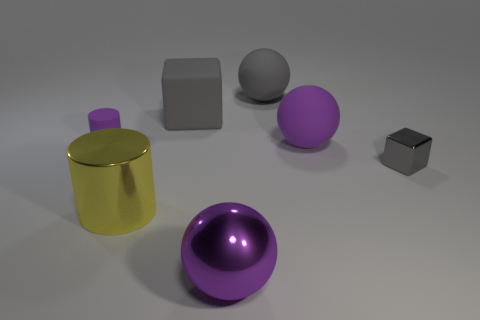Add 1 purple rubber cylinders. How many objects exist? 8 Subtract all balls. How many objects are left? 4 Add 1 tiny gray metal blocks. How many tiny gray metal blocks exist? 2 Subtract 2 gray blocks. How many objects are left? 5 Subtract all tiny shiny blocks. Subtract all tiny blocks. How many objects are left? 5 Add 6 yellow cylinders. How many yellow cylinders are left? 7 